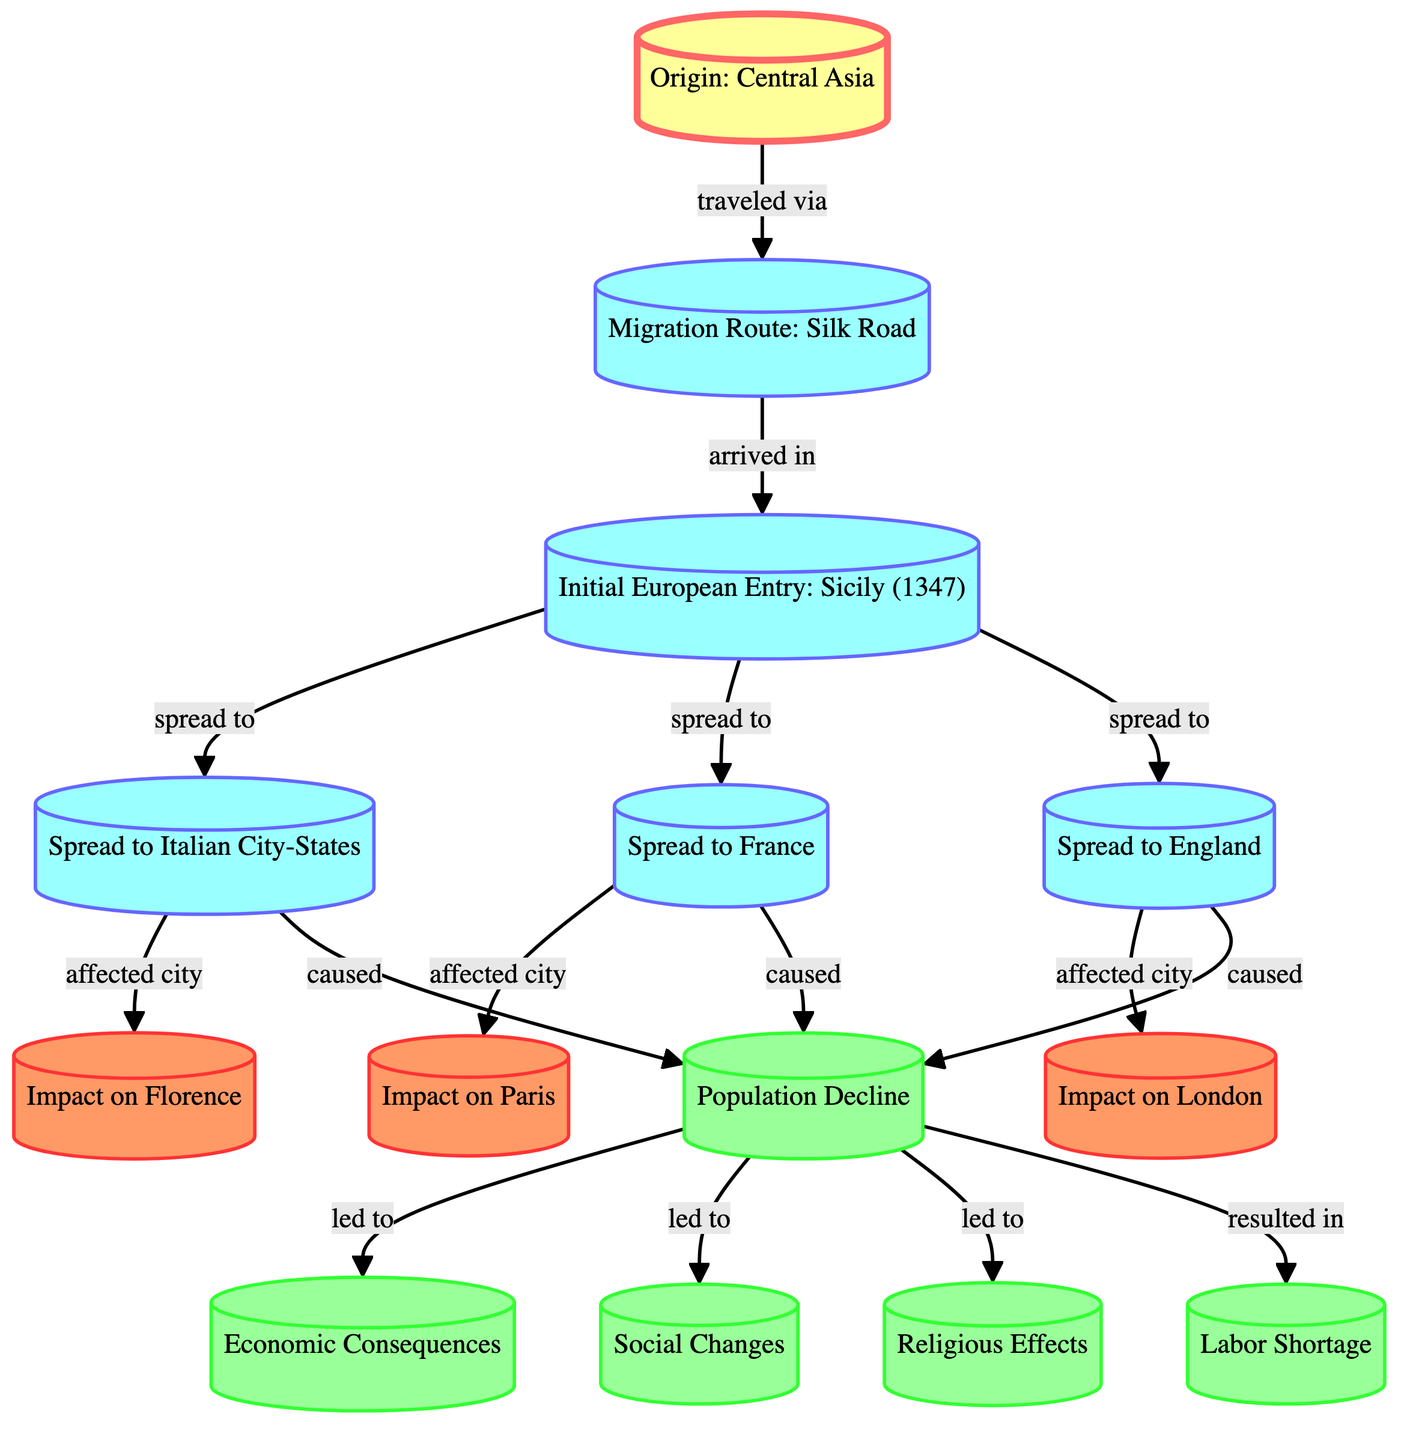What is the origin of the Black Death? The diagram indicates that the origin of the Black Death is "Central Asia," which is shown as the first node in the graph.
Answer: Central Asia Which migration route did the Black Death take to arrive in Europe? The graph shows that the Black Death traveled via the "Silk Road," depicted as a connection from the origin node to the incidence in European territory.
Answer: Silk Road What was the first location in Europe where the Black Death entered? The diagram identifies "Sicily (1347)" as the initial entry point for the Black Death into Europe directly connected to the migration route node.
Answer: Sicily (1347) Which cities were affected by the spread from the initial entry point? The graph indicates that the spread from Sicily led to impacts in three major areas: the "Italian City-States," "France," and "England," as shown by the arrows diverging from the initial entry node.
Answer: Italian City-States, France, England How many cities were impacted by the spread of the Black Death? Analyzing the diagram, we see connections representing the impact of the Black Death on three cities: Florence, Paris, and London, which are all linked to their respective country nodes.
Answer: 3 What was the consequence of the population decline caused by the Black Death? According to the diagram, the direct consequence of population decline is linked to multiple outcomes, including "Economic Consequences," "Social Changes," "Religious Effects," and "Labor Shortage." Each outcome related to the population decline node reflects broader historical impacts.
Answer: Economic Consequences, Social Changes, Religious Effects, Labor Shortage How does the impact on Florence relate to the population decline? The graph indicates a direct link, with Florence impacted by the spread to the "Italian City-States," leading to a "Population Decline," showing a clear cause-and-effect relationship in the graph.
Answer: Impact on Florence What specific effects did the population decline lead to? The directed graph elaborates that from the "Population Decline," several specific effects were generated, notably leading to "Economic Consequences," "Social Changes," "Religious Effects," and a notable "Labor Shortage." This shows how each outcome builds from the central theme of population decline.
Answer: Economic Consequences, Social Changes, Religious Effects, Labor Shortage What type of relationship connects the origin to the migration route? The graph specifies the relationship type connecting these nodes as "traveled via," which shows how the origin of the Black Death is linked to its migration route through the Silk Road.
Answer: traveled via 